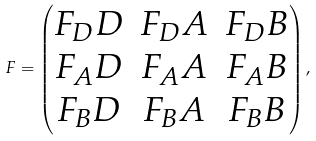<formula> <loc_0><loc_0><loc_500><loc_500>F = \begin{pmatrix} F _ { D } D & F _ { D } A & F _ { D } B \\ F _ { A } D & F _ { A } A & F _ { A } B \\ F _ { B } D & F _ { B } A & F _ { B } B \end{pmatrix} ,</formula> 